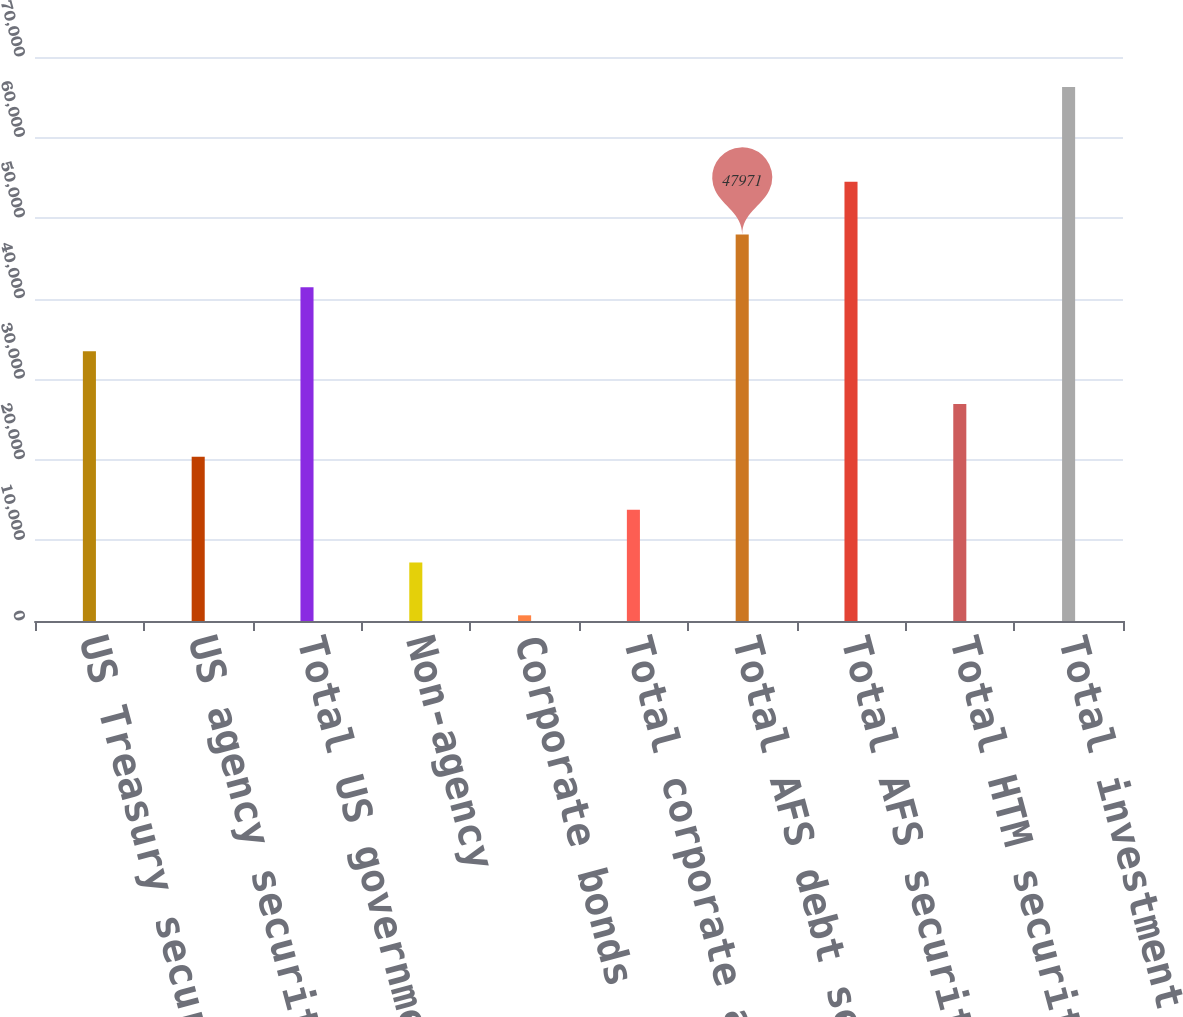<chart> <loc_0><loc_0><loc_500><loc_500><bar_chart><fcel>US Treasury securities<fcel>US agency securities<fcel>Total US government and agency<fcel>Non-agency<fcel>Corporate bonds<fcel>Total corporate and other debt<fcel>Total AFS debt securities<fcel>Total AFS securities<fcel>Total HTM securities<fcel>Total investment securities<nl><fcel>33490<fcel>20376<fcel>41414<fcel>7262<fcel>705<fcel>13819<fcel>47971<fcel>54528<fcel>26933<fcel>66275<nl></chart> 